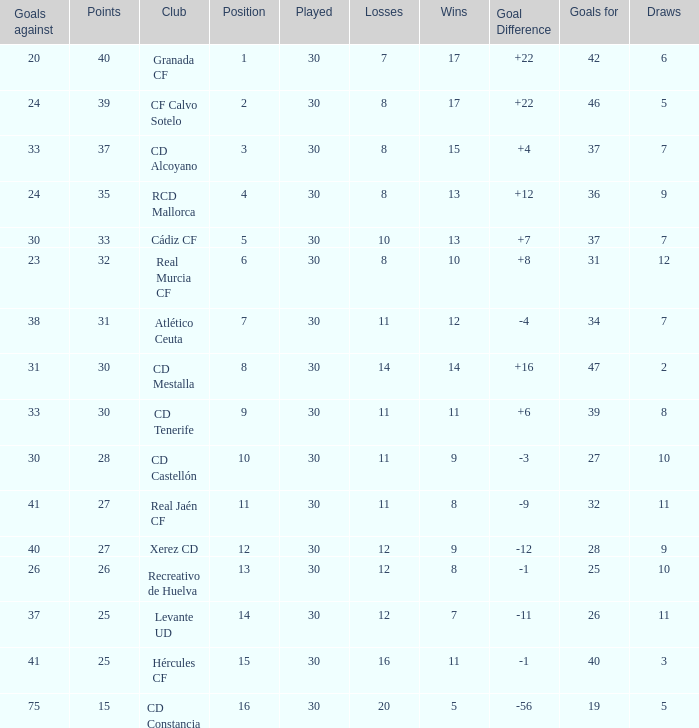How many Draws have 30 Points, and less than 33 Goals against? 1.0. 